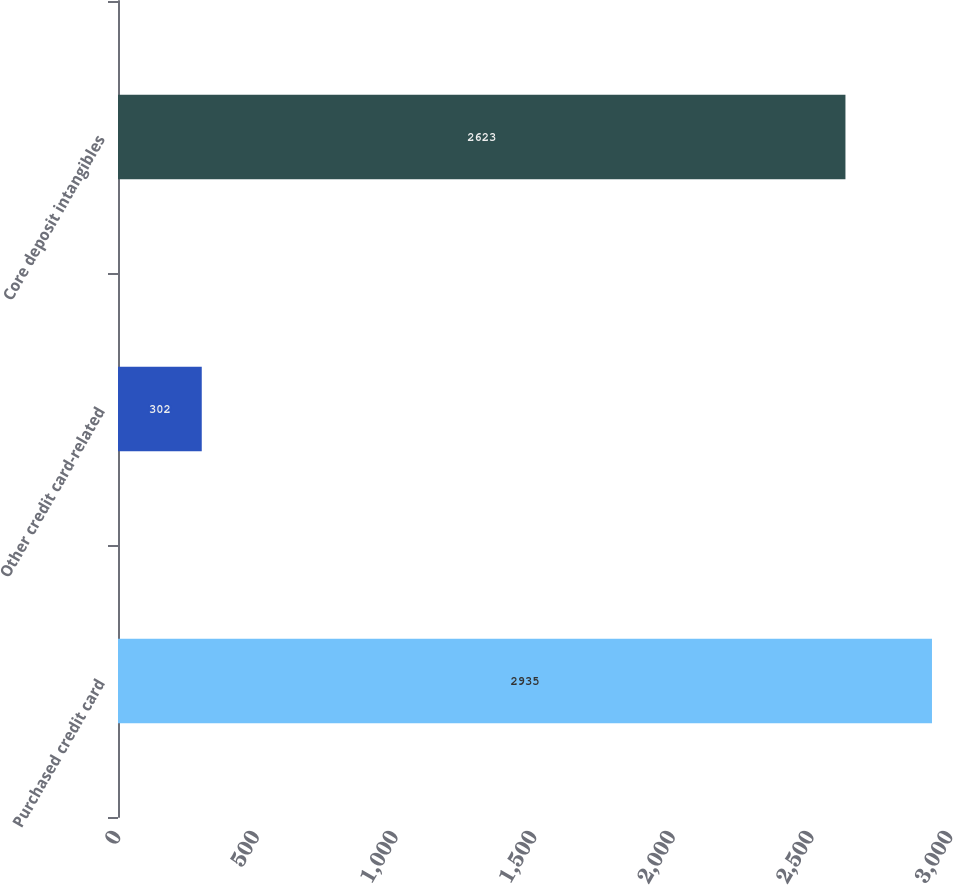Convert chart. <chart><loc_0><loc_0><loc_500><loc_500><bar_chart><fcel>Purchased credit card<fcel>Other credit card-related<fcel>Core deposit intangibles<nl><fcel>2935<fcel>302<fcel>2623<nl></chart> 